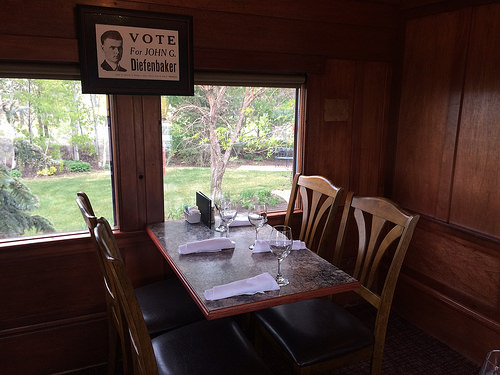<image>
Can you confirm if the chair is next to the table? Yes. The chair is positioned adjacent to the table, located nearby in the same general area. 